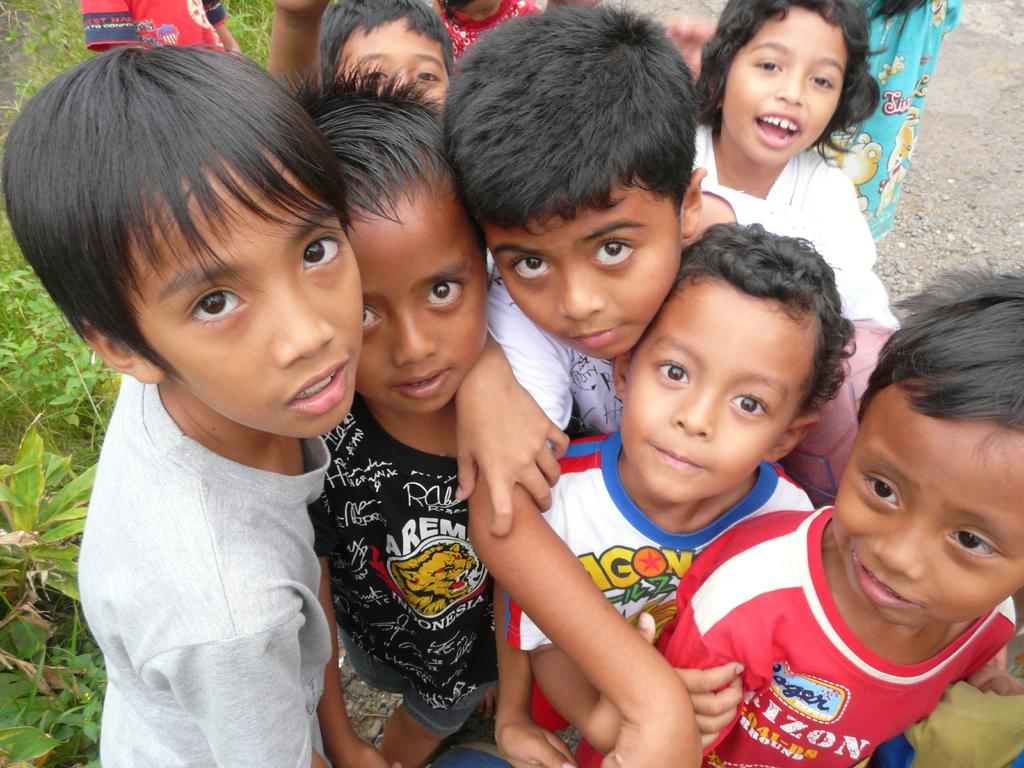What is the main subject of the image? The main subject of the image is kids in the center. What can be seen on the right side of the image? There is land on the right side of the image. What is present on the left side of the image? There are plants on the left side of the image. Where is the mom holding the calculator in the image? There is no mom or calculator present in the image. What type of scissors can be seen cutting the plants in the image? There are no scissors or cutting activity involving plants in the image. 